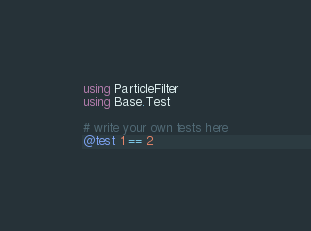<code> <loc_0><loc_0><loc_500><loc_500><_Julia_>using ParticleFilter
using Base.Test

# write your own tests here
@test 1 == 2
</code> 